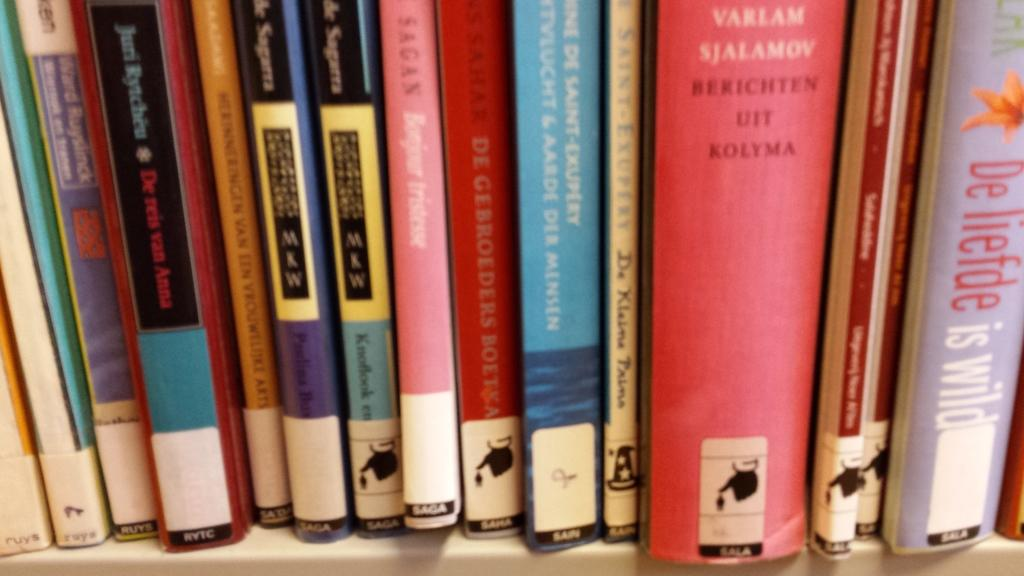<image>
Create a compact narrative representing the image presented. Various books with labels near the bottom denoting SAGA, SALA, RVTC etc. 